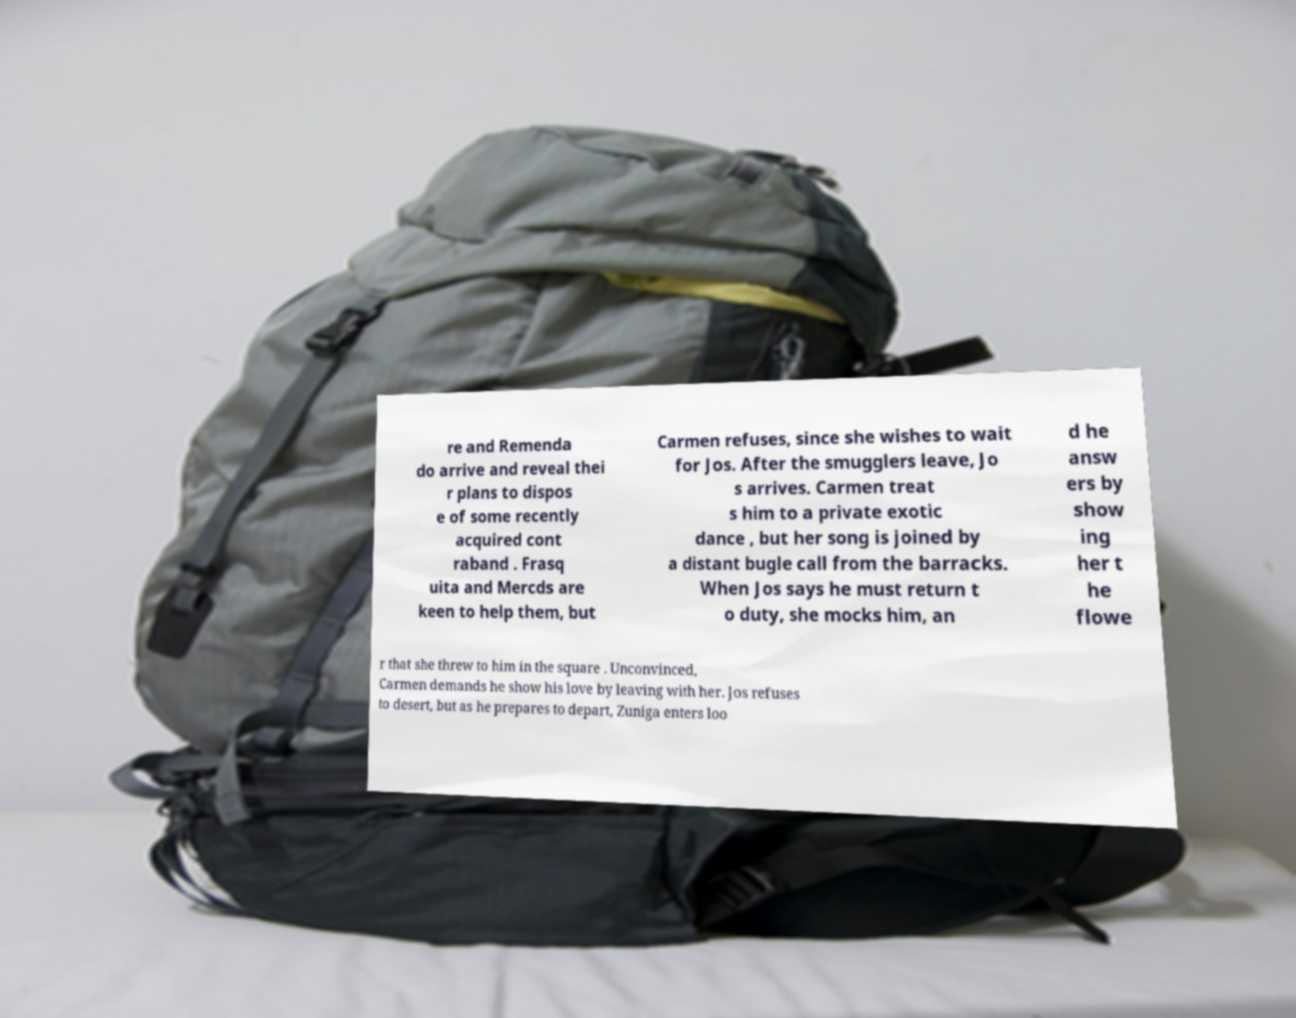Can you accurately transcribe the text from the provided image for me? re and Remenda do arrive and reveal thei r plans to dispos e of some recently acquired cont raband . Frasq uita and Mercds are keen to help them, but Carmen refuses, since she wishes to wait for Jos. After the smugglers leave, Jo s arrives. Carmen treat s him to a private exotic dance , but her song is joined by a distant bugle call from the barracks. When Jos says he must return t o duty, she mocks him, an d he answ ers by show ing her t he flowe r that she threw to him in the square . Unconvinced, Carmen demands he show his love by leaving with her. Jos refuses to desert, but as he prepares to depart, Zuniga enters loo 